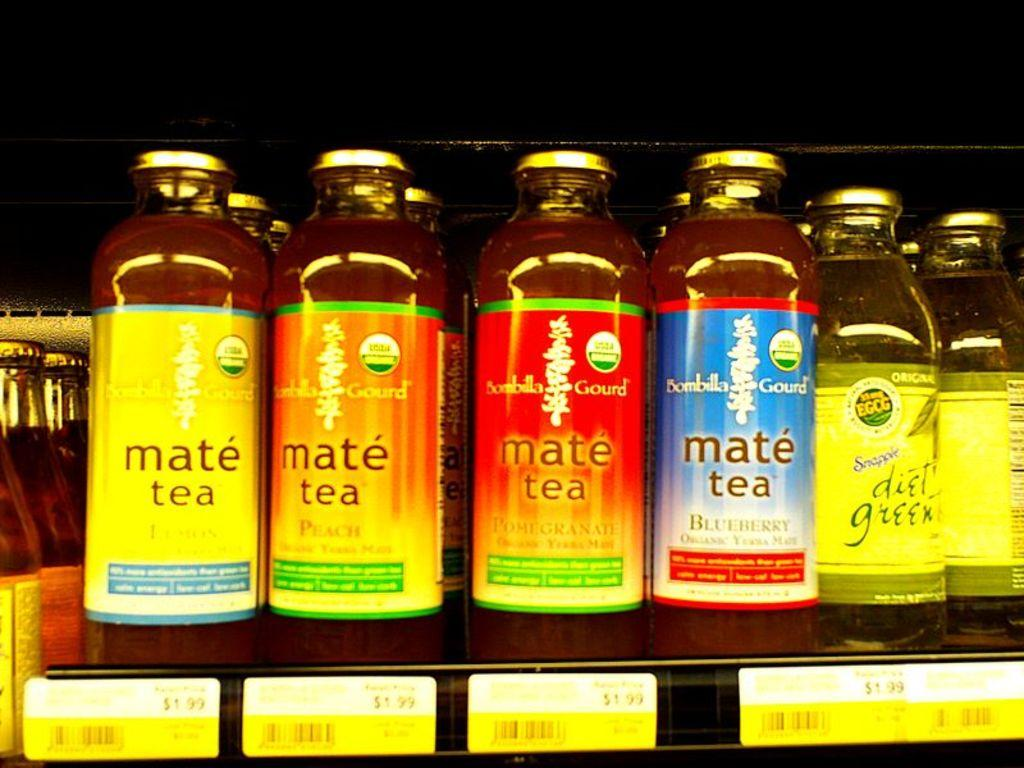<image>
Write a terse but informative summary of the picture. Several bottles of mate tea are on a retail shelf. 